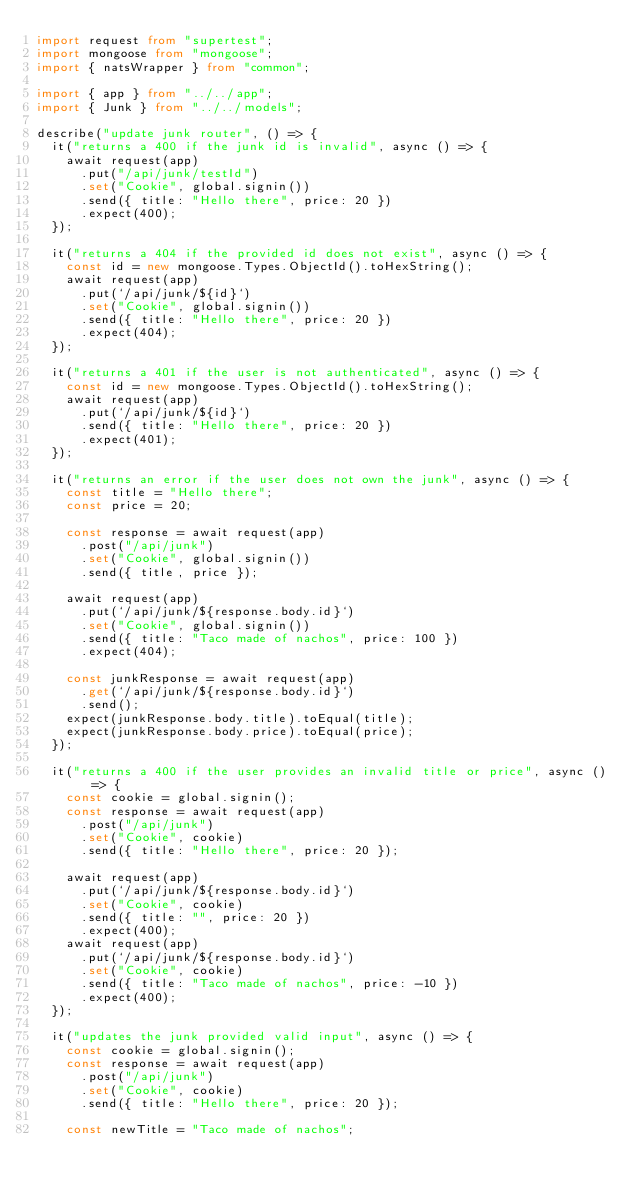<code> <loc_0><loc_0><loc_500><loc_500><_TypeScript_>import request from "supertest";
import mongoose from "mongoose";
import { natsWrapper } from "common";

import { app } from "../../app";
import { Junk } from "../../models";

describe("update junk router", () => {
  it("returns a 400 if the junk id is invalid", async () => {
    await request(app)
      .put("/api/junk/testId")
      .set("Cookie", global.signin())
      .send({ title: "Hello there", price: 20 })
      .expect(400);
  });

  it("returns a 404 if the provided id does not exist", async () => {
    const id = new mongoose.Types.ObjectId().toHexString();
    await request(app)
      .put(`/api/junk/${id}`)
      .set("Cookie", global.signin())
      .send({ title: "Hello there", price: 20 })
      .expect(404);
  });

  it("returns a 401 if the user is not authenticated", async () => {
    const id = new mongoose.Types.ObjectId().toHexString();
    await request(app)
      .put(`/api/junk/${id}`)
      .send({ title: "Hello there", price: 20 })
      .expect(401);
  });

  it("returns an error if the user does not own the junk", async () => {
    const title = "Hello there";
    const price = 20;

    const response = await request(app)
      .post("/api/junk")
      .set("Cookie", global.signin())
      .send({ title, price });

    await request(app)
      .put(`/api/junk/${response.body.id}`)
      .set("Cookie", global.signin())
      .send({ title: "Taco made of nachos", price: 100 })
      .expect(404);

    const junkResponse = await request(app)
      .get(`/api/junk/${response.body.id}`)
      .send();
    expect(junkResponse.body.title).toEqual(title);
    expect(junkResponse.body.price).toEqual(price);
  });

  it("returns a 400 if the user provides an invalid title or price", async () => {
    const cookie = global.signin();
    const response = await request(app)
      .post("/api/junk")
      .set("Cookie", cookie)
      .send({ title: "Hello there", price: 20 });

    await request(app)
      .put(`/api/junk/${response.body.id}`)
      .set("Cookie", cookie)
      .send({ title: "", price: 20 })
      .expect(400);
    await request(app)
      .put(`/api/junk/${response.body.id}`)
      .set("Cookie", cookie)
      .send({ title: "Taco made of nachos", price: -10 })
      .expect(400);
  });

  it("updates the junk provided valid input", async () => {
    const cookie = global.signin();
    const response = await request(app)
      .post("/api/junk")
      .set("Cookie", cookie)
      .send({ title: "Hello there", price: 20 });

    const newTitle = "Taco made of nachos";</code> 